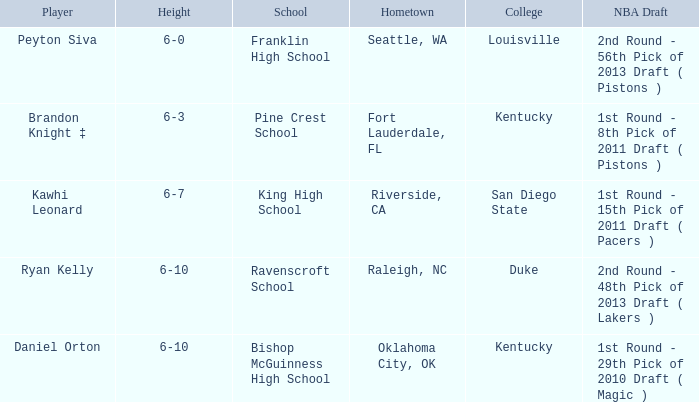Which school is in Raleigh, NC? Ravenscroft School. 